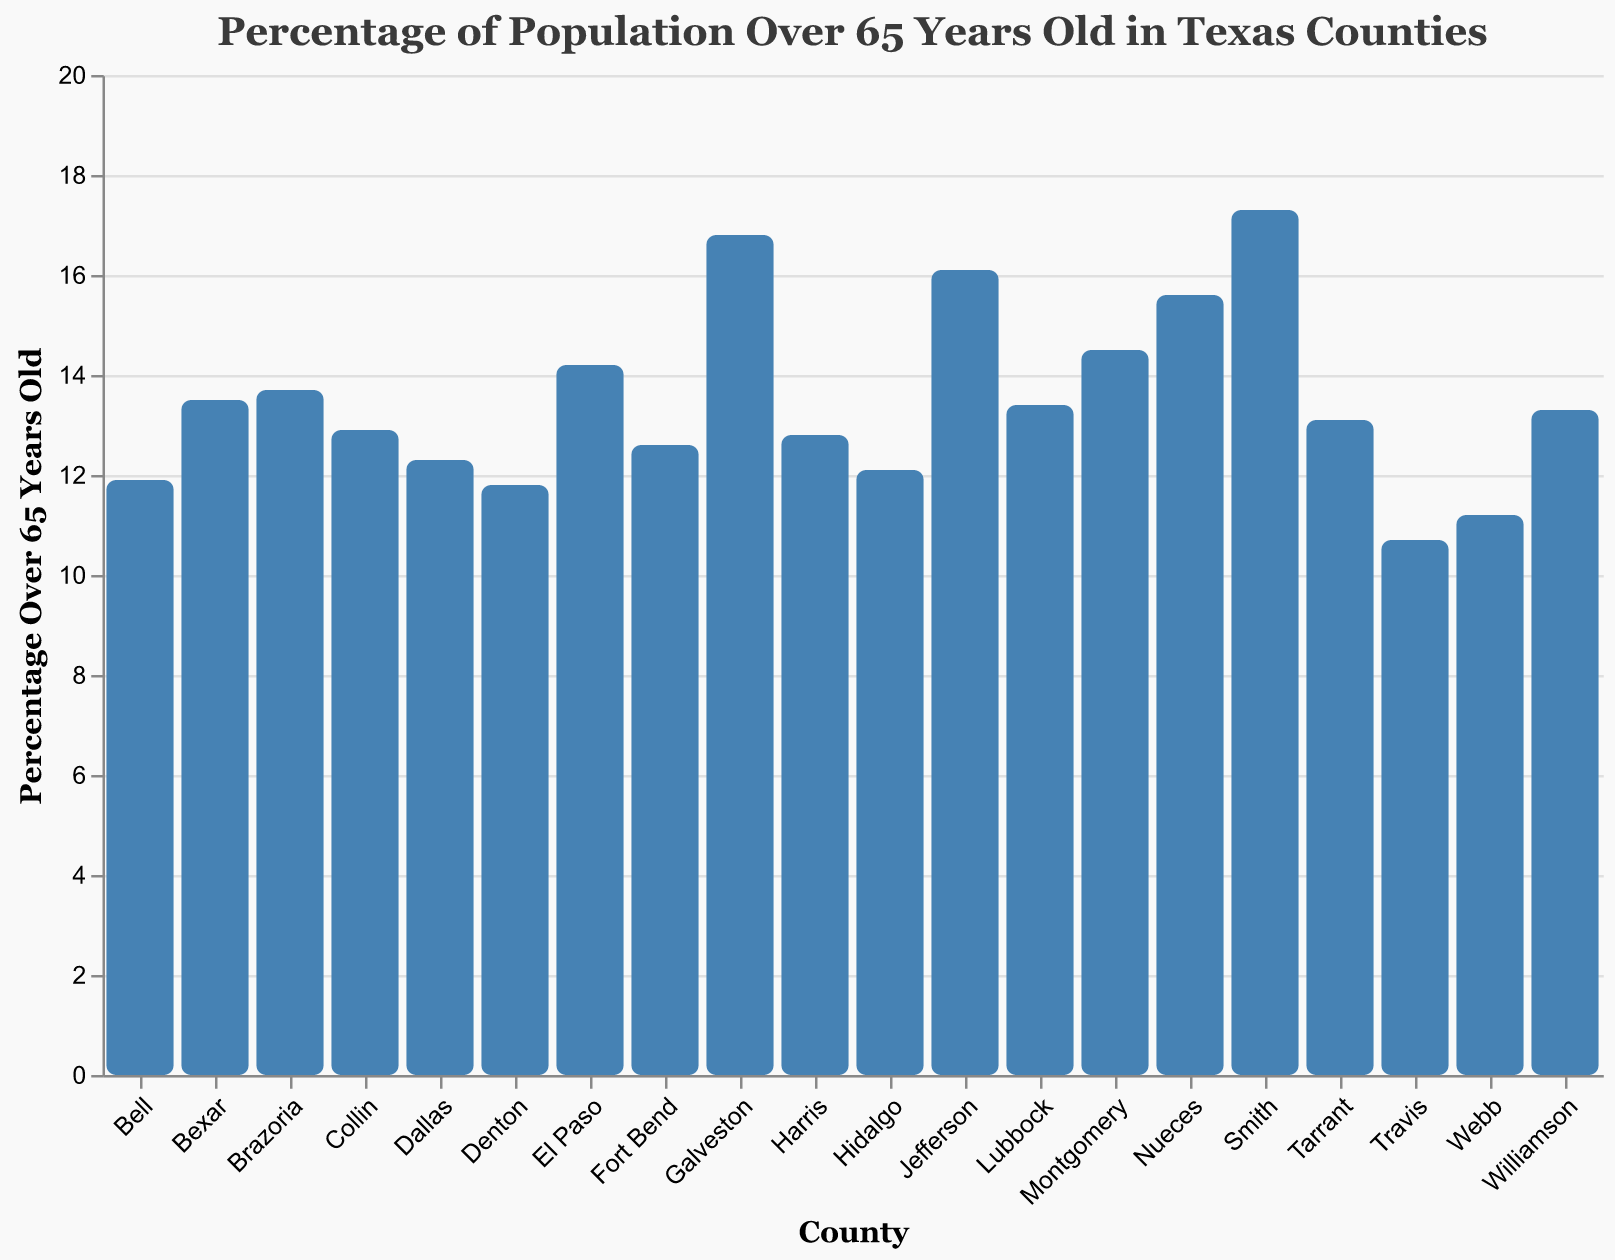What's the title of the figure? The title of the figure is written at the top and reads "Percentage of Population Over 65 Years Old in Texas Counties".
Answer: Percentage of Population Over 65 Years Old in Texas Counties Which county has the highest percentage of population over 65 years old? To find the county with the highest percentage, look for the tallest bar in the plot, which corresponds to Smith County.
Answer: Smith Which county has the lowest percentage of population over 65 years old? To find the county with the lowest percentage, look for the shortest bar in the plot, which corresponds to Travis County.
Answer: Travis What is the percentage of population over 65 years old in El Paso County? Find El Paso County on the x-axis and look at the height of its respective bar to read the percentage, which is 14.2%.
Answer: 14.2% How many counties have a percentage of population over 65 years old above 15%? Identify all counties where the bar height is above 15% (Galveston, Nueces, Jefferson, Smith) and count them. There are four such counties.
Answer: 4 What's the average percentage of population over 65 years old in Harris, Dallas, and Tarrant counties? Sum the percentages of Harris (12.8), Dallas (12.3), and Tarrant (13.1), then divide by 3. The calculation is (12.8 + 12.3 + 13.1) / 3 = 12.73%.
Answer: 12.73% Which of these counties has a higher percentage of population over 65 years old: Bexar or Brazoria? Compare the percentages for Bexar (13.5) and Brazoria (13.7), and Brazoria County has a higher percentage.
Answer: Brazoria What is the difference between the highest and the lowest percentages of population over 65 years old? Identify the highest percentage (Smith at 17.3%) and the lowest percentage (Travis at 10.7%), and calculate the difference: 17.3 - 10.7 = 6.6%.
Answer: 6.6% Is the percentage of population over 65 years old higher in Collin County or El Paso County? Compare the percentages for Collin (12.9) and El Paso (14.2), and El Paso County has a higher percentage.
Answer: El Paso List all counties with a percentage of population over 65 years old between 12% and 14%. Identify the counties with percentages in the 12-14% range from the axis: Harris (12.8), Dallas (12.3), Tarrant (13.1), Collin (12.9), Denton (11.8), Fort Bend (12.6), Williamson (13.3), and Hidalgo (12.1). Denton County (11.8%) is just below 12%.
Answer: Harris, Dallas, Tarrant, Collin, Fort Bend, Williamson, Hidalgo 